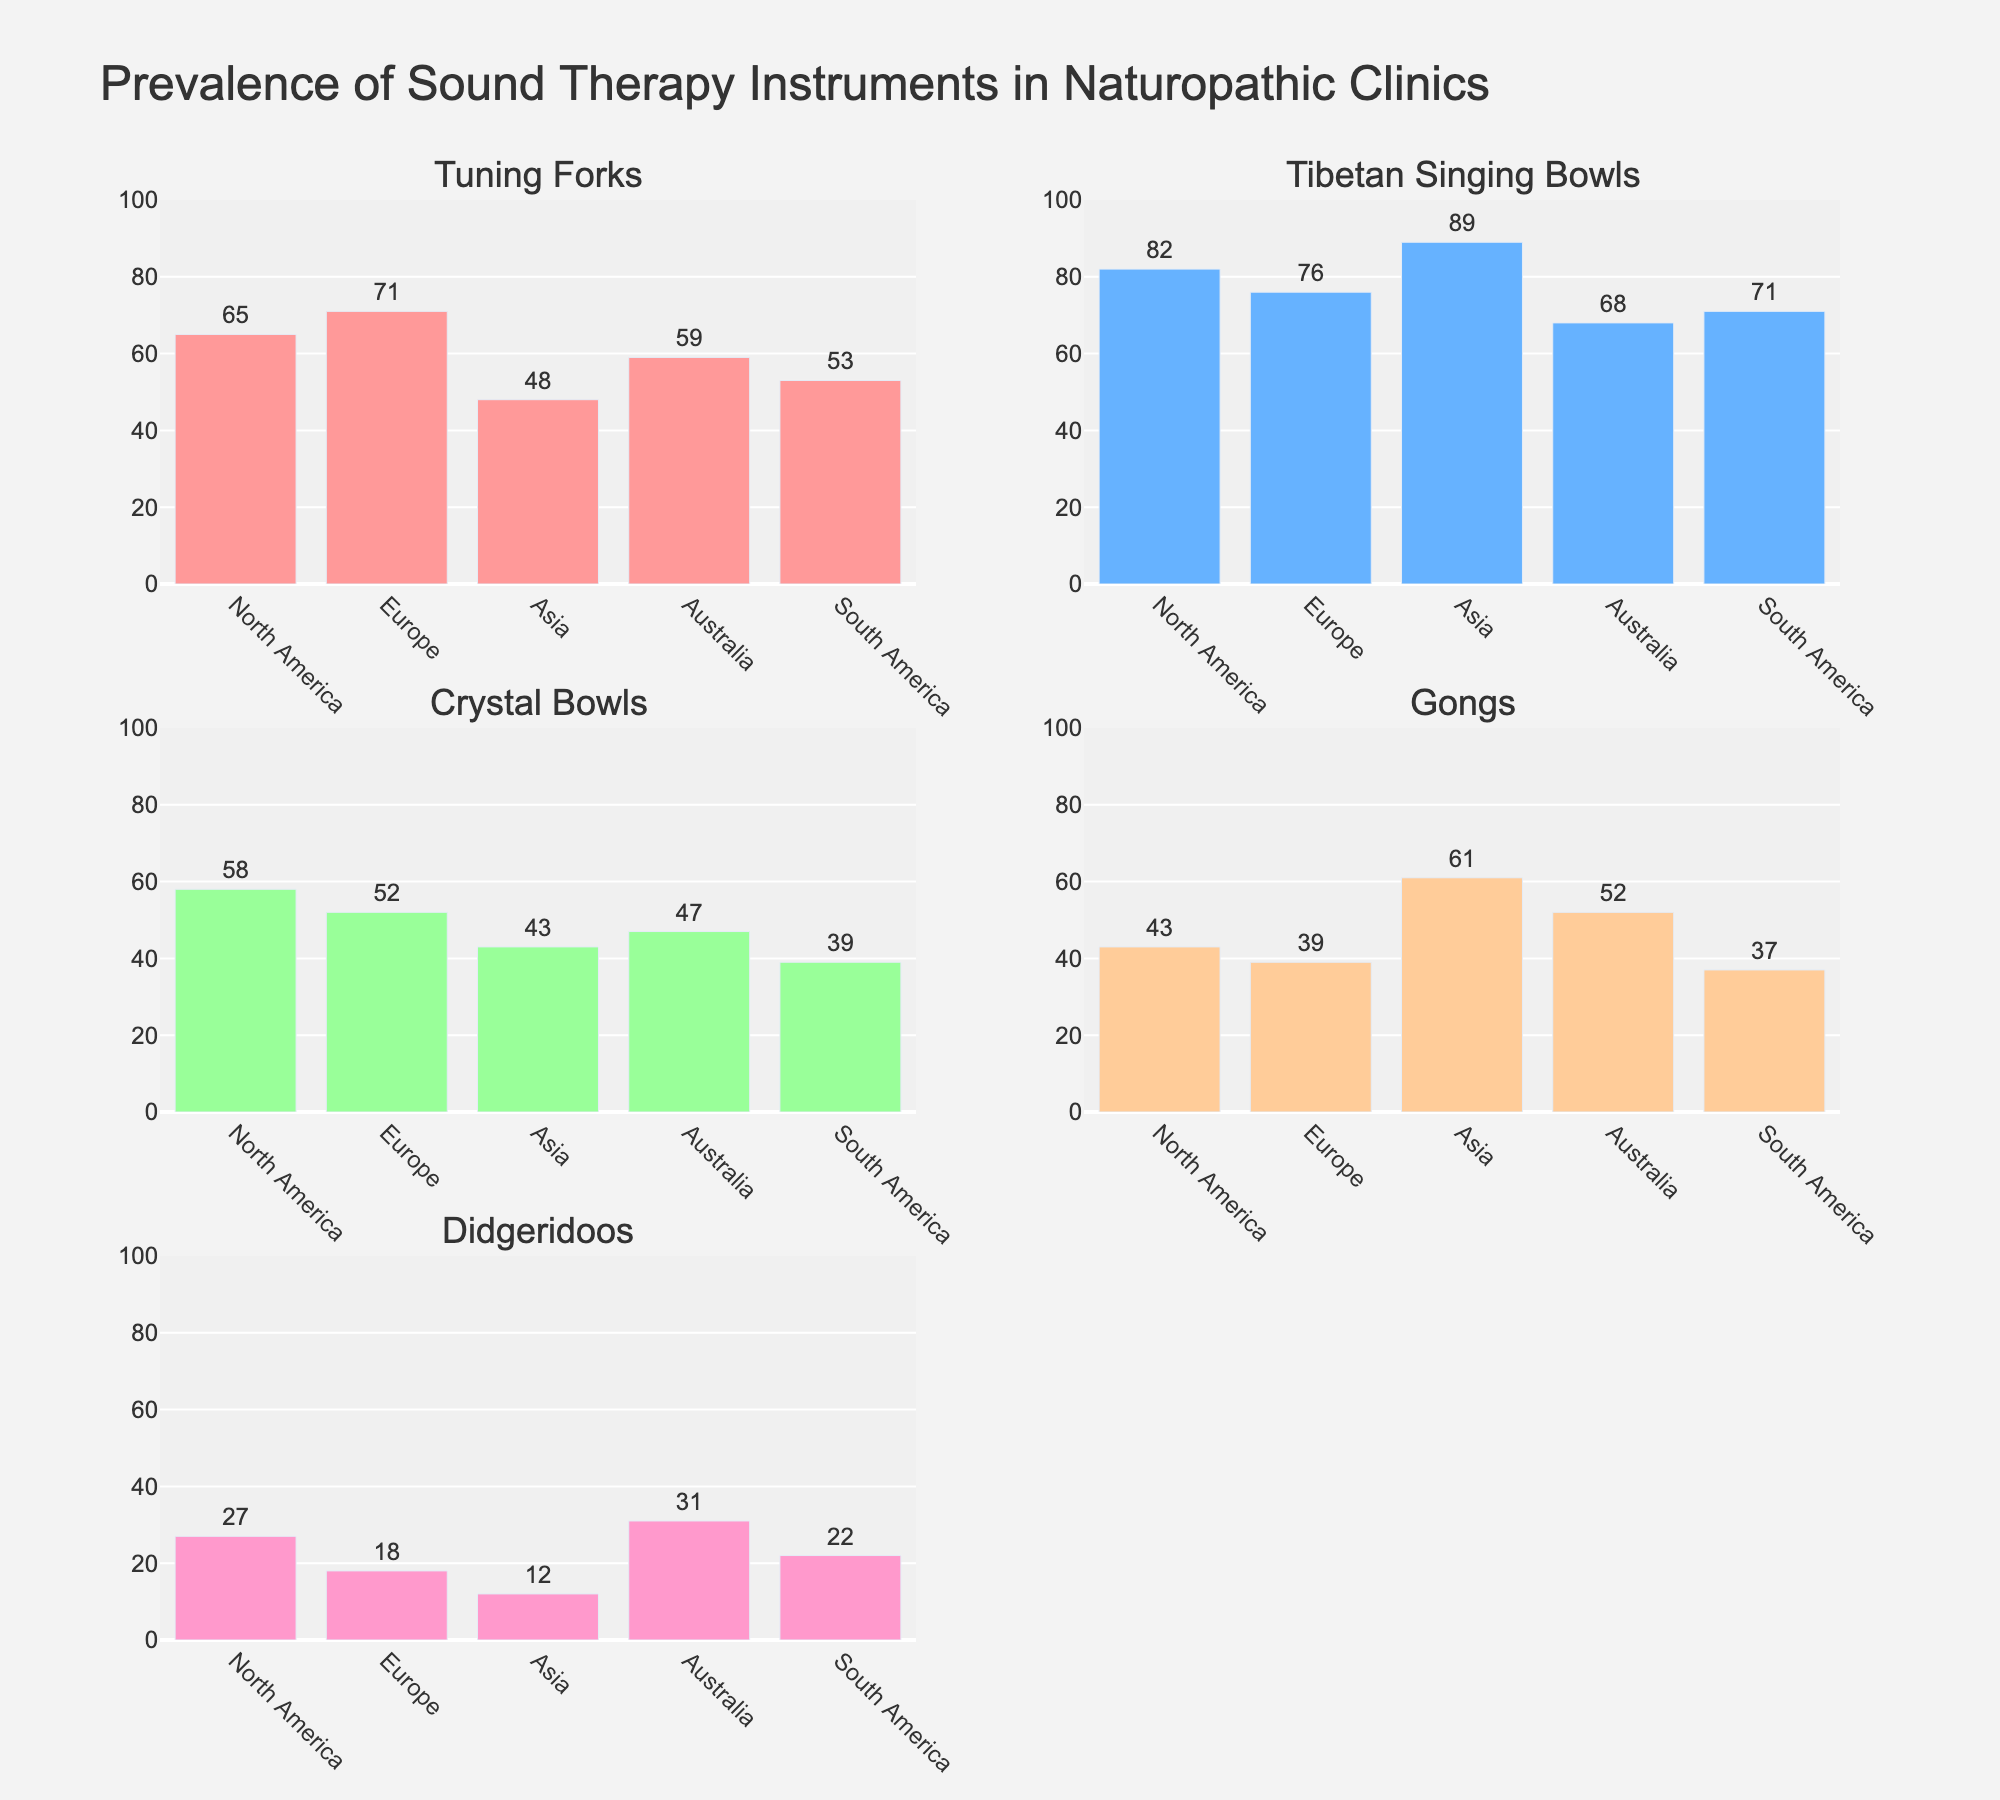What's the most used sound therapy instrument in North America? The bar with the highest value for North America represents the most used instrument. By checking the chart for North America, the instrument with the highest bar is Tibetan Singing Bowls at 82.
Answer: Tibetan Singing Bowls Which region has the lowest prevalence of Didgeridoos? Look for the shortest bar in the "Didgeridoos" subplot to find the region with the lowest prevalence. Comparing the bars, Asia has the shortest bar at 12.
Answer: Asia What's the average use of Crystal Bowls across all regions? Sum the values of Crystal Bowls (58 + 52 + 43 + 47 + 39) which equals 239. Then divide by the 5 regions: 239 / 5 = 47.8.
Answer: 47.8 Compare the prevalence of Gongs in Asia and Australia. Which region uses them more? Locate and compare the bars for Gongs in the Asia and Australia subplots. Asia's bar is at 61 while Australia's bar is at 52. Asia uses them more.
Answer: Asia What is the difference in the prevalence of Tuning Forks between North America and Europe? Subtract the value for Europe from the value for North America: 71 - 65 = 6.
Answer: 6 Which region has the highest prevalence of any musical instrument? Identify the highest single bar across all subplots and regions. The highest bar is for Tibetan Singing Bowls in Asia at 89.
Answer: Asia How does the prevalence of Tibetan Singing Bowls compare between North America and Europe? Compare the bars for Tibetan Singing Bowls in North America and Europe. North America has 82, while Europe has 76. North America uses them more.
Answer: North America Is the use of Didgeridoos greater in Australia compared to South America? Compare the bars for Didgeridoos in Australia and South America. Australia's bar is at 31 while South America's bar is at 22. Australia uses them more.
Answer: Australia What is the total prevalence of Gongs across all regions? Sum the values for Gongs: 43 + 39 + 61 + 52 + 37 = 232.
Answer: 232 Which instrument shows the most consistent usage across all regions, and what is the range of its usage? Check each instrument’s values across regions and compare their ranges. Crystal Bowls have the smallest range from 39 to 58.
Answer: Crystal Bowls, range of 19 